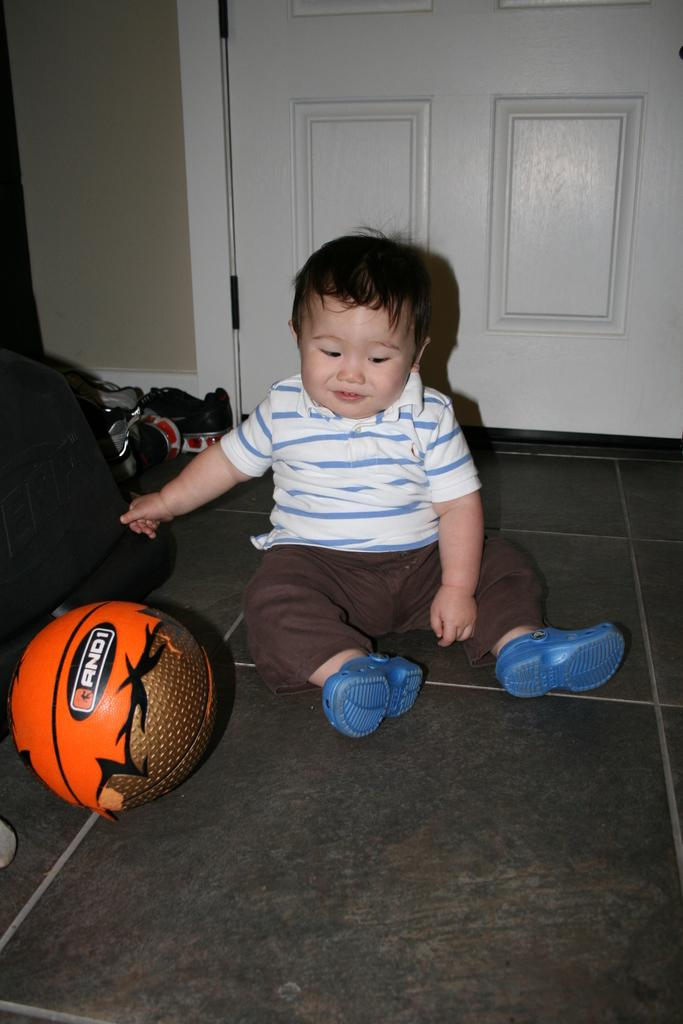What is the position of the kid in the image? The kid is sitting on the floor in the image. What is the kid doing in the image? The kid is touching an object in the image. What can be seen to the left of the kid? There are a few objects and a ball to the left of the kid. What is visible on the wall behind the kid? There is a door on the wall behind the kid. How heavy is the icicle hanging from the ceiling in the image? There is no icicle present in the image, so it is not possible to determine its weight. 